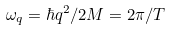Convert formula to latex. <formula><loc_0><loc_0><loc_500><loc_500>\omega _ { q } = \hbar { q } ^ { 2 } / 2 M = 2 \pi / T</formula> 